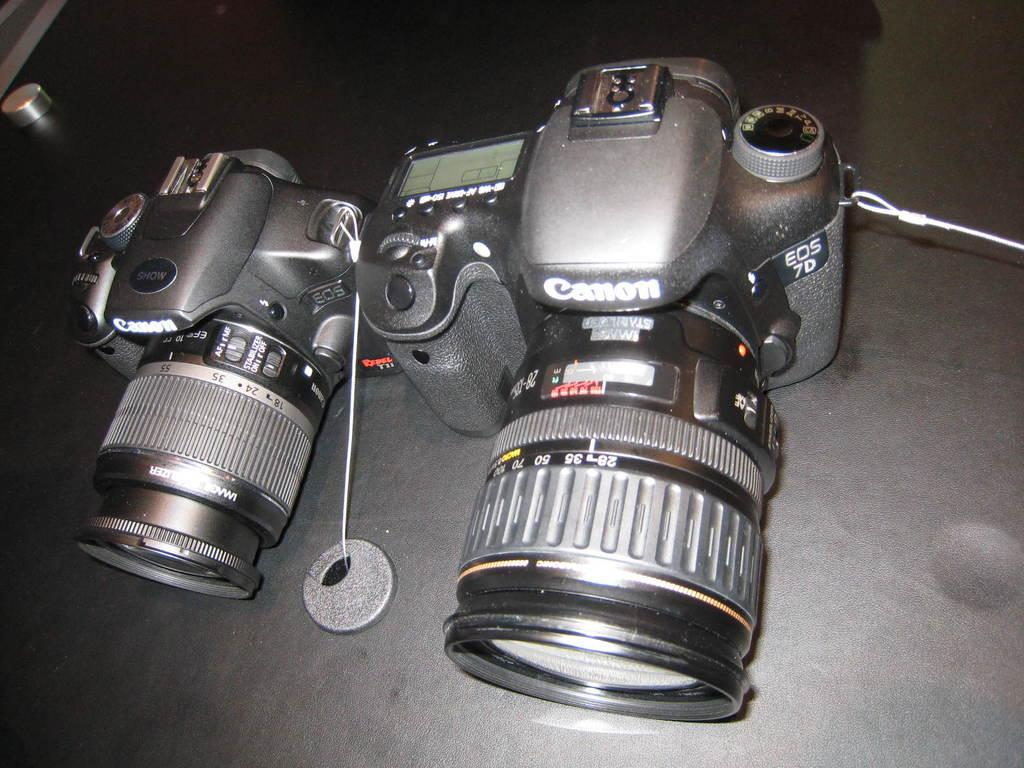What is the main subject of the image? The main subject of the image is a camera. Can you describe the object on a black surface in the image? Unfortunately, the facts provided do not give any details about the object on the black surface. However, we can confirm that there is an object on a black surface in the image. How many chickens can be seen in the image? There are no chickens present in the image. What color are the eyes of the camera in the image? Cameras do not have eyes, so this question cannot be answered. 